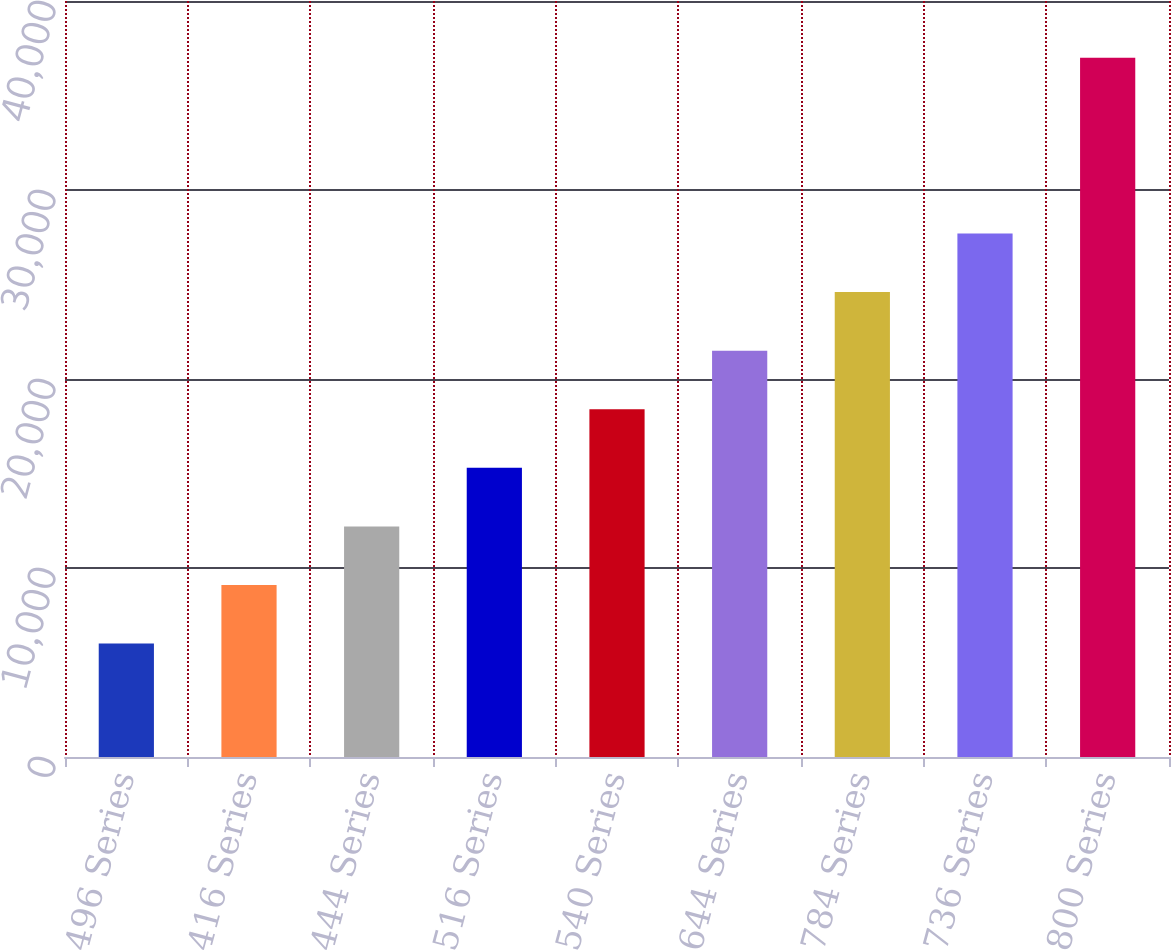Convert chart to OTSL. <chart><loc_0><loc_0><loc_500><loc_500><bar_chart><fcel>496 Series<fcel>416 Series<fcel>444 Series<fcel>516 Series<fcel>540 Series<fcel>644 Series<fcel>784 Series<fcel>736 Series<fcel>800 Series<nl><fcel>6000<fcel>9100<fcel>12200<fcel>15300<fcel>18400<fcel>21500<fcel>24600<fcel>27700<fcel>37000<nl></chart> 